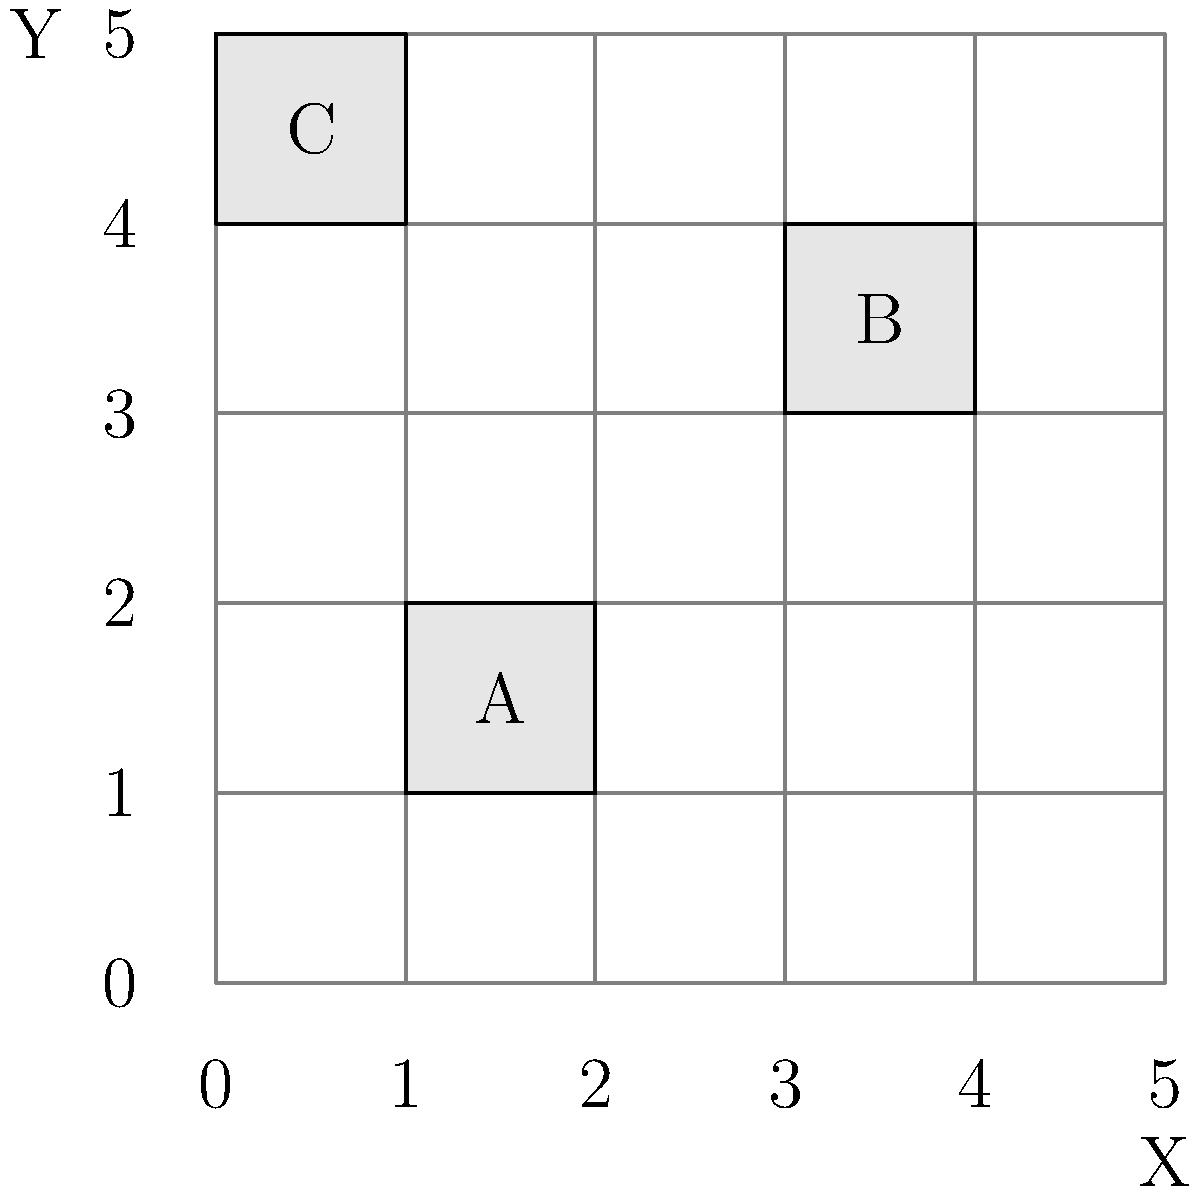In the archival storage system shown above, boxes are placed on a 5x5 grid with coordinates (X, Y). If you need to retrieve box B, what are its coordinates? To determine the coordinates of box B, we need to follow these steps:

1. Identify box B on the grid: Box B is located in the upper right quadrant of the grid.

2. Determine the X-coordinate:
   - The left edge of box B aligns with the gridline marked 3 on the X-axis.
   - The box occupies one full unit on the X-axis.
   - Therefore, the X-coordinate is 3.

3. Determine the Y-coordinate:
   - The bottom edge of box B aligns with the gridline marked 3 on the Y-axis.
   - The box occupies one full unit on the Y-axis.
   - Therefore, the Y-coordinate is 3.

4. Combine the coordinates:
   - The coordinates are expressed as (X, Y).
   - For box B, this gives us (3, 3).

Thus, to retrieve box B, you would look for the item stored at coordinates (3, 3) in the archival storage system.
Answer: (3, 3) 